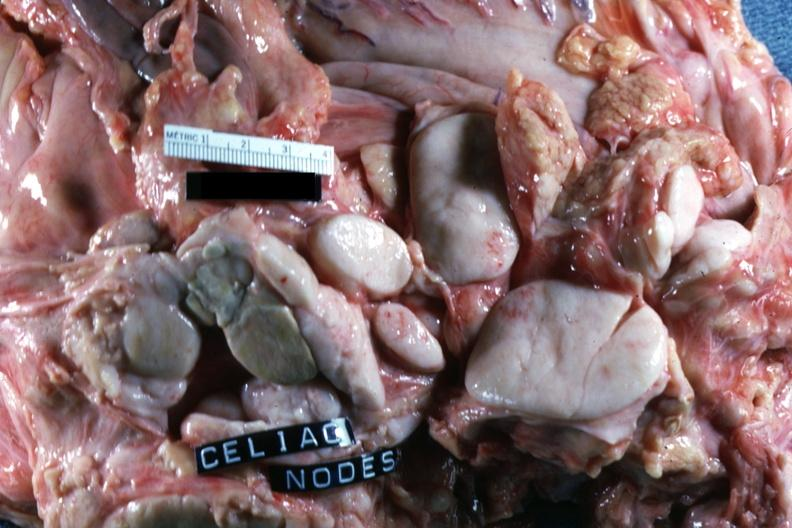how does this image show sectioned nodes?
Answer the question using a single word or phrase. With ivory white color 